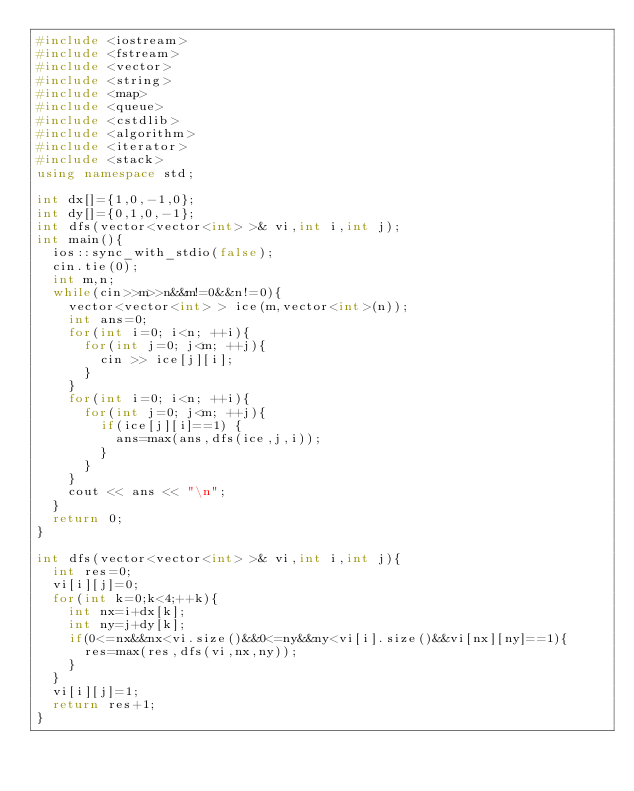<code> <loc_0><loc_0><loc_500><loc_500><_C++_>#include <iostream>
#include <fstream>
#include <vector>
#include <string>
#include <map>
#include <queue>
#include <cstdlib>
#include <algorithm>
#include <iterator>
#include <stack>
using namespace std;

int dx[]={1,0,-1,0};
int dy[]={0,1,0,-1};
int dfs(vector<vector<int> >& vi,int i,int j);
int main(){
	ios::sync_with_stdio(false);
	cin.tie(0);
	int m,n;
	while(cin>>m>>n&&m!=0&&n!=0){
		vector<vector<int> > ice(m,vector<int>(n));
		int ans=0;
		for(int i=0; i<n; ++i){
			for(int j=0; j<m; ++j){
				cin >> ice[j][i];
			}
		}
		for(int i=0; i<n; ++i){
			for(int j=0; j<m; ++j){
				if(ice[j][i]==1) {
					ans=max(ans,dfs(ice,j,i));
				}
			}
		}
		cout << ans << "\n";
	}
	return 0;
}

int dfs(vector<vector<int> >& vi,int i,int j){
	int res=0;
	vi[i][j]=0;
	for(int k=0;k<4;++k){
		int nx=i+dx[k];
		int ny=j+dy[k];
		if(0<=nx&&nx<vi.size()&&0<=ny&&ny<vi[i].size()&&vi[nx][ny]==1){
			res=max(res,dfs(vi,nx,ny));
		}
	}
	vi[i][j]=1;
	return res+1;
}</code> 